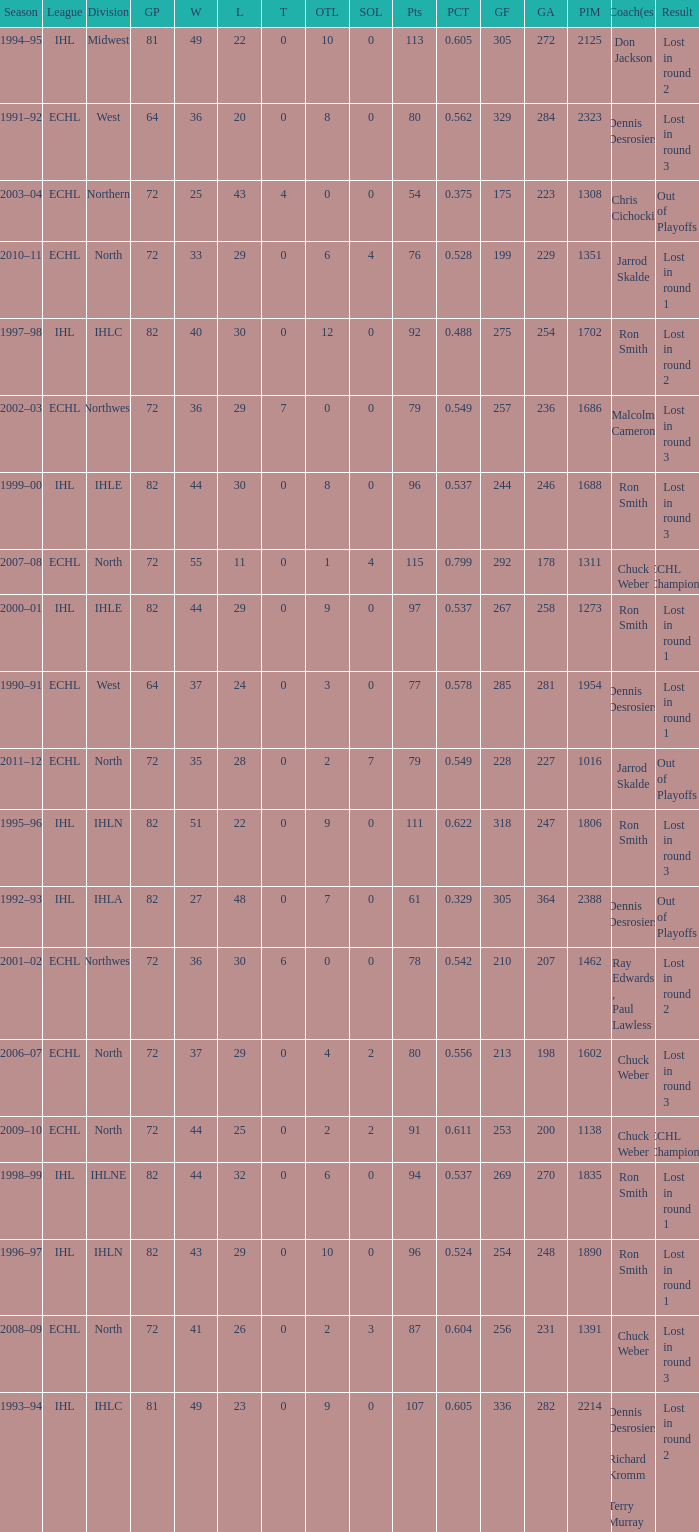How many season did the team lost in round 1 with a GP of 64? 1.0. 